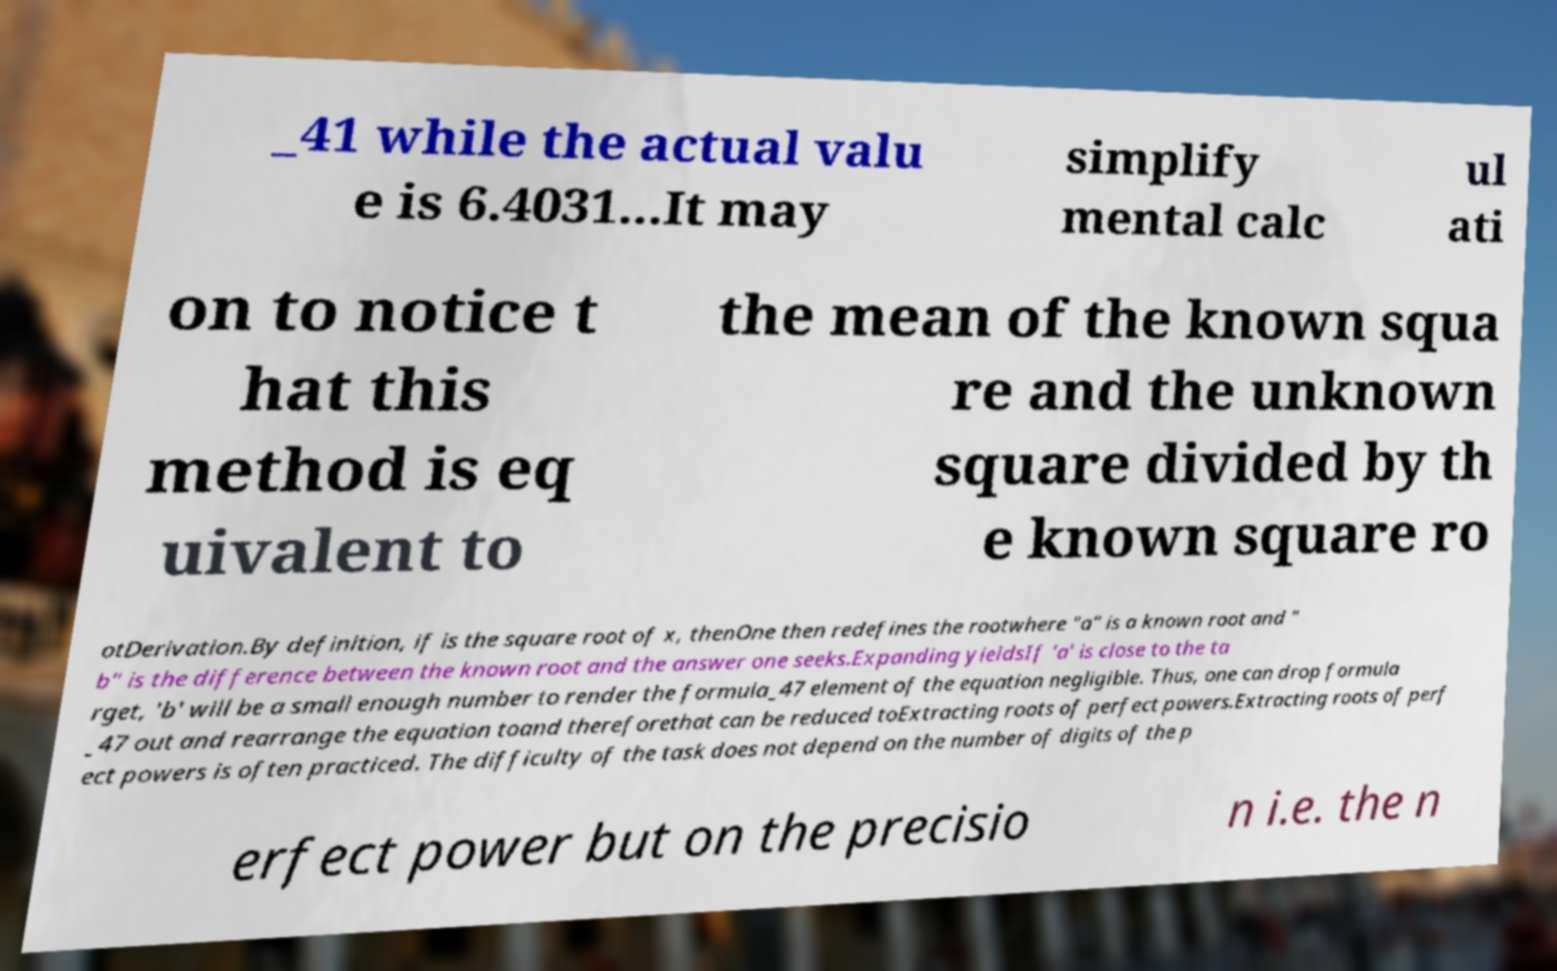Could you assist in decoding the text presented in this image and type it out clearly? _41 while the actual valu e is 6.4031...It may simplify mental calc ul ati on to notice t hat this method is eq uivalent to the mean of the known squa re and the unknown square divided by th e known square ro otDerivation.By definition, if is the square root of x, thenOne then redefines the rootwhere "a" is a known root and " b" is the difference between the known root and the answer one seeks.Expanding yieldsIf 'a' is close to the ta rget, 'b' will be a small enough number to render the formula_47 element of the equation negligible. Thus, one can drop formula _47 out and rearrange the equation toand thereforethat can be reduced toExtracting roots of perfect powers.Extracting roots of perf ect powers is often practiced. The difficulty of the task does not depend on the number of digits of the p erfect power but on the precisio n i.e. the n 